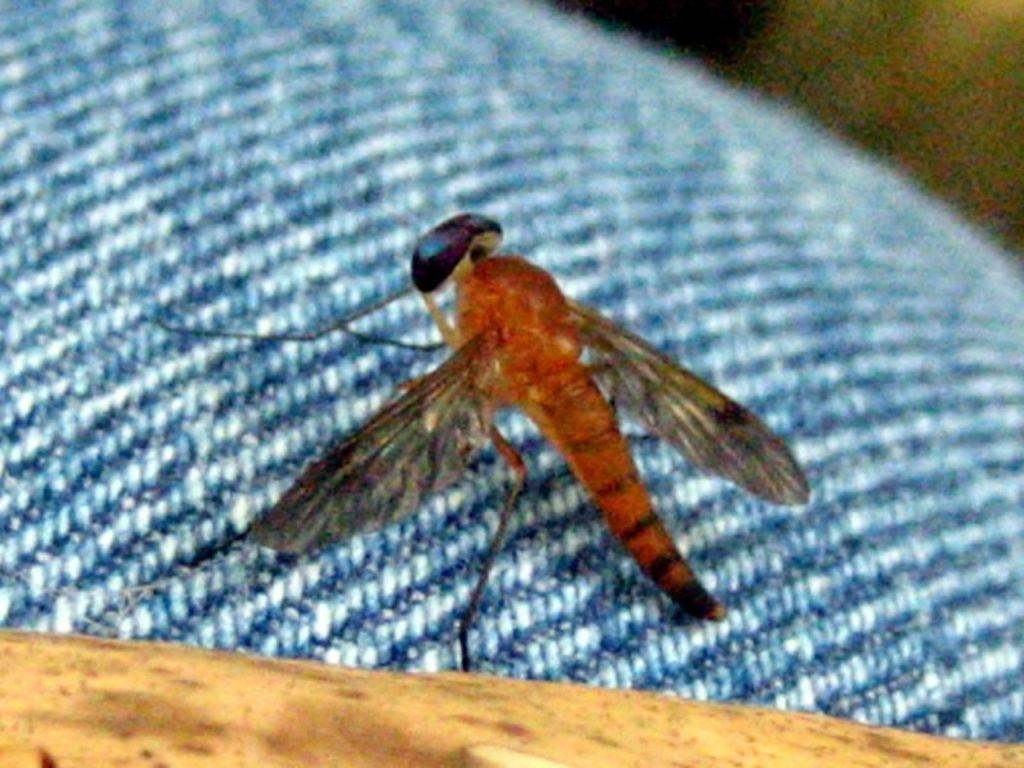What is present in the image? There is an insect in the image. What is the insect sitting on? The insect is on a blue color cloth. What type of wood is the insect using to build its nest in the image? There is no wood or nest visible in the image; it only features an insect on a blue color cloth. 